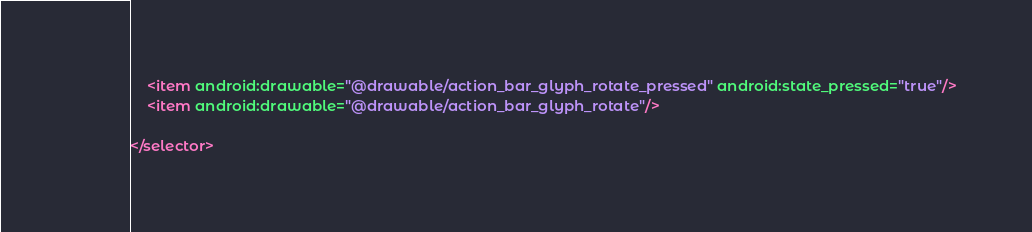Convert code to text. <code><loc_0><loc_0><loc_500><loc_500><_XML_>    <item android:drawable="@drawable/action_bar_glyph_rotate_pressed" android:state_pressed="true"/>
    <item android:drawable="@drawable/action_bar_glyph_rotate"/>

</selector></code> 